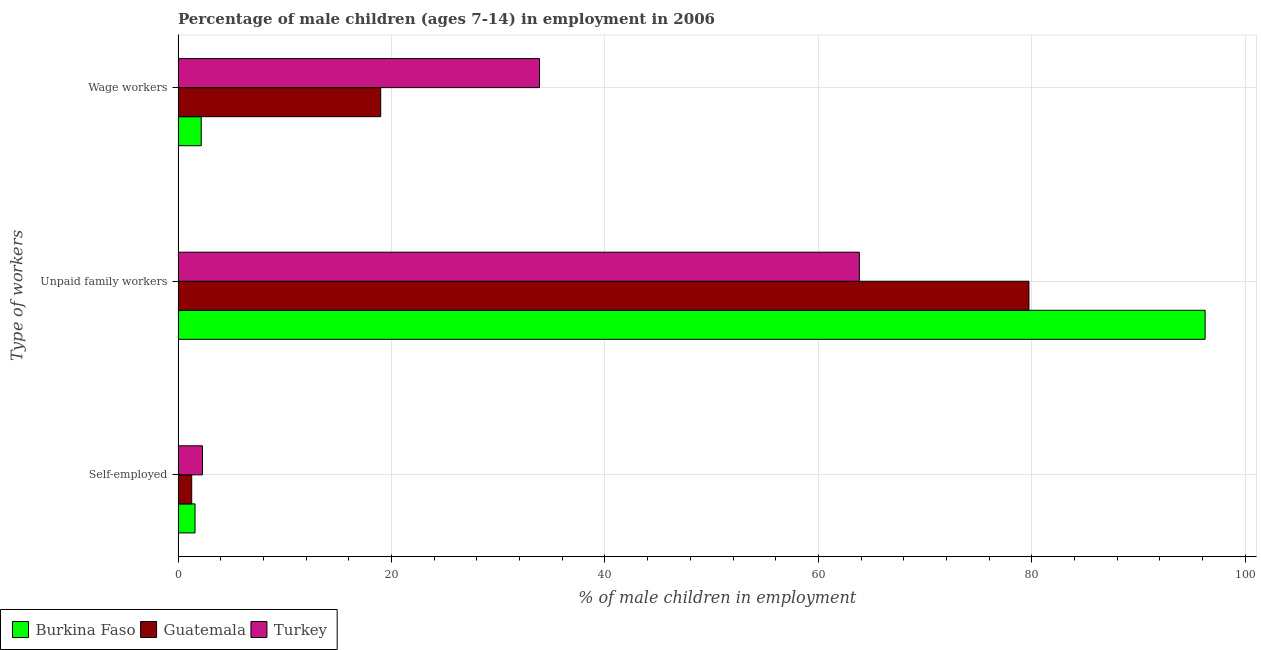How many groups of bars are there?
Offer a terse response. 3. Are the number of bars on each tick of the Y-axis equal?
Your response must be concise. Yes. How many bars are there on the 1st tick from the bottom?
Give a very brief answer. 3. What is the label of the 2nd group of bars from the top?
Your answer should be very brief. Unpaid family workers. What is the percentage of children employed as wage workers in Turkey?
Provide a succinct answer. 33.87. Across all countries, what is the maximum percentage of children employed as unpaid family workers?
Provide a succinct answer. 96.24. Across all countries, what is the minimum percentage of children employed as wage workers?
Make the answer very short. 2.17. In which country was the percentage of children employed as unpaid family workers maximum?
Offer a very short reply. Burkina Faso. What is the total percentage of children employed as unpaid family workers in the graph?
Provide a short and direct response. 239.81. What is the difference between the percentage of children employed as wage workers in Burkina Faso and that in Guatemala?
Provide a succinct answer. -16.82. What is the difference between the percentage of children employed as wage workers in Guatemala and the percentage of self employed children in Burkina Faso?
Your response must be concise. 17.4. What is the average percentage of self employed children per country?
Offer a terse response. 1.72. What is the difference between the percentage of self employed children and percentage of children employed as unpaid family workers in Guatemala?
Offer a very short reply. -78.45. What is the ratio of the percentage of children employed as wage workers in Guatemala to that in Turkey?
Your response must be concise. 0.56. Is the difference between the percentage of children employed as wage workers in Turkey and Guatemala greater than the difference between the percentage of self employed children in Turkey and Guatemala?
Provide a succinct answer. Yes. What is the difference between the highest and the second highest percentage of children employed as wage workers?
Your response must be concise. 14.88. In how many countries, is the percentage of self employed children greater than the average percentage of self employed children taken over all countries?
Provide a succinct answer. 1. Is the sum of the percentage of children employed as unpaid family workers in Burkina Faso and Turkey greater than the maximum percentage of children employed as wage workers across all countries?
Your response must be concise. Yes. What does the 2nd bar from the top in Wage workers represents?
Make the answer very short. Guatemala. What does the 2nd bar from the bottom in Self-employed represents?
Make the answer very short. Guatemala. How many bars are there?
Give a very brief answer. 9. Are all the bars in the graph horizontal?
Your answer should be compact. Yes. What is the difference between two consecutive major ticks on the X-axis?
Your answer should be compact. 20. Are the values on the major ticks of X-axis written in scientific E-notation?
Your response must be concise. No. Does the graph contain any zero values?
Offer a very short reply. No. Does the graph contain grids?
Your response must be concise. Yes. How many legend labels are there?
Offer a very short reply. 3. How are the legend labels stacked?
Keep it short and to the point. Horizontal. What is the title of the graph?
Ensure brevity in your answer.  Percentage of male children (ages 7-14) in employment in 2006. What is the label or title of the X-axis?
Make the answer very short. % of male children in employment. What is the label or title of the Y-axis?
Ensure brevity in your answer.  Type of workers. What is the % of male children in employment of Burkina Faso in Self-employed?
Your response must be concise. 1.59. What is the % of male children in employment in Guatemala in Self-employed?
Make the answer very short. 1.28. What is the % of male children in employment in Turkey in Self-employed?
Offer a very short reply. 2.29. What is the % of male children in employment of Burkina Faso in Unpaid family workers?
Give a very brief answer. 96.24. What is the % of male children in employment of Guatemala in Unpaid family workers?
Ensure brevity in your answer.  79.73. What is the % of male children in employment in Turkey in Unpaid family workers?
Offer a terse response. 63.84. What is the % of male children in employment of Burkina Faso in Wage workers?
Make the answer very short. 2.17. What is the % of male children in employment in Guatemala in Wage workers?
Make the answer very short. 18.99. What is the % of male children in employment of Turkey in Wage workers?
Make the answer very short. 33.87. Across all Type of workers, what is the maximum % of male children in employment in Burkina Faso?
Your answer should be very brief. 96.24. Across all Type of workers, what is the maximum % of male children in employment of Guatemala?
Offer a very short reply. 79.73. Across all Type of workers, what is the maximum % of male children in employment in Turkey?
Provide a succinct answer. 63.84. Across all Type of workers, what is the minimum % of male children in employment in Burkina Faso?
Ensure brevity in your answer.  1.59. Across all Type of workers, what is the minimum % of male children in employment of Guatemala?
Offer a very short reply. 1.28. Across all Type of workers, what is the minimum % of male children in employment of Turkey?
Ensure brevity in your answer.  2.29. What is the total % of male children in employment in Guatemala in the graph?
Give a very brief answer. 100. What is the total % of male children in employment of Turkey in the graph?
Your answer should be very brief. 100. What is the difference between the % of male children in employment of Burkina Faso in Self-employed and that in Unpaid family workers?
Keep it short and to the point. -94.65. What is the difference between the % of male children in employment of Guatemala in Self-employed and that in Unpaid family workers?
Your response must be concise. -78.45. What is the difference between the % of male children in employment in Turkey in Self-employed and that in Unpaid family workers?
Your answer should be very brief. -61.55. What is the difference between the % of male children in employment of Burkina Faso in Self-employed and that in Wage workers?
Your answer should be very brief. -0.58. What is the difference between the % of male children in employment of Guatemala in Self-employed and that in Wage workers?
Give a very brief answer. -17.71. What is the difference between the % of male children in employment of Turkey in Self-employed and that in Wage workers?
Offer a terse response. -31.58. What is the difference between the % of male children in employment of Burkina Faso in Unpaid family workers and that in Wage workers?
Your answer should be very brief. 94.07. What is the difference between the % of male children in employment in Guatemala in Unpaid family workers and that in Wage workers?
Your answer should be compact. 60.74. What is the difference between the % of male children in employment of Turkey in Unpaid family workers and that in Wage workers?
Make the answer very short. 29.97. What is the difference between the % of male children in employment in Burkina Faso in Self-employed and the % of male children in employment in Guatemala in Unpaid family workers?
Make the answer very short. -78.14. What is the difference between the % of male children in employment of Burkina Faso in Self-employed and the % of male children in employment of Turkey in Unpaid family workers?
Your answer should be compact. -62.25. What is the difference between the % of male children in employment in Guatemala in Self-employed and the % of male children in employment in Turkey in Unpaid family workers?
Provide a short and direct response. -62.56. What is the difference between the % of male children in employment in Burkina Faso in Self-employed and the % of male children in employment in Guatemala in Wage workers?
Provide a succinct answer. -17.4. What is the difference between the % of male children in employment of Burkina Faso in Self-employed and the % of male children in employment of Turkey in Wage workers?
Ensure brevity in your answer.  -32.28. What is the difference between the % of male children in employment in Guatemala in Self-employed and the % of male children in employment in Turkey in Wage workers?
Make the answer very short. -32.59. What is the difference between the % of male children in employment of Burkina Faso in Unpaid family workers and the % of male children in employment of Guatemala in Wage workers?
Ensure brevity in your answer.  77.25. What is the difference between the % of male children in employment in Burkina Faso in Unpaid family workers and the % of male children in employment in Turkey in Wage workers?
Offer a very short reply. 62.37. What is the difference between the % of male children in employment in Guatemala in Unpaid family workers and the % of male children in employment in Turkey in Wage workers?
Your answer should be very brief. 45.86. What is the average % of male children in employment of Burkina Faso per Type of workers?
Ensure brevity in your answer.  33.33. What is the average % of male children in employment in Guatemala per Type of workers?
Your response must be concise. 33.33. What is the average % of male children in employment in Turkey per Type of workers?
Offer a terse response. 33.33. What is the difference between the % of male children in employment in Burkina Faso and % of male children in employment in Guatemala in Self-employed?
Provide a succinct answer. 0.31. What is the difference between the % of male children in employment in Guatemala and % of male children in employment in Turkey in Self-employed?
Provide a succinct answer. -1.01. What is the difference between the % of male children in employment of Burkina Faso and % of male children in employment of Guatemala in Unpaid family workers?
Your answer should be very brief. 16.51. What is the difference between the % of male children in employment of Burkina Faso and % of male children in employment of Turkey in Unpaid family workers?
Provide a short and direct response. 32.4. What is the difference between the % of male children in employment in Guatemala and % of male children in employment in Turkey in Unpaid family workers?
Give a very brief answer. 15.89. What is the difference between the % of male children in employment in Burkina Faso and % of male children in employment in Guatemala in Wage workers?
Make the answer very short. -16.82. What is the difference between the % of male children in employment of Burkina Faso and % of male children in employment of Turkey in Wage workers?
Provide a succinct answer. -31.7. What is the difference between the % of male children in employment in Guatemala and % of male children in employment in Turkey in Wage workers?
Your response must be concise. -14.88. What is the ratio of the % of male children in employment in Burkina Faso in Self-employed to that in Unpaid family workers?
Keep it short and to the point. 0.02. What is the ratio of the % of male children in employment of Guatemala in Self-employed to that in Unpaid family workers?
Keep it short and to the point. 0.02. What is the ratio of the % of male children in employment of Turkey in Self-employed to that in Unpaid family workers?
Make the answer very short. 0.04. What is the ratio of the % of male children in employment of Burkina Faso in Self-employed to that in Wage workers?
Ensure brevity in your answer.  0.73. What is the ratio of the % of male children in employment in Guatemala in Self-employed to that in Wage workers?
Ensure brevity in your answer.  0.07. What is the ratio of the % of male children in employment in Turkey in Self-employed to that in Wage workers?
Your response must be concise. 0.07. What is the ratio of the % of male children in employment of Burkina Faso in Unpaid family workers to that in Wage workers?
Make the answer very short. 44.35. What is the ratio of the % of male children in employment in Guatemala in Unpaid family workers to that in Wage workers?
Provide a short and direct response. 4.2. What is the ratio of the % of male children in employment in Turkey in Unpaid family workers to that in Wage workers?
Provide a succinct answer. 1.88. What is the difference between the highest and the second highest % of male children in employment in Burkina Faso?
Keep it short and to the point. 94.07. What is the difference between the highest and the second highest % of male children in employment in Guatemala?
Provide a short and direct response. 60.74. What is the difference between the highest and the second highest % of male children in employment of Turkey?
Offer a very short reply. 29.97. What is the difference between the highest and the lowest % of male children in employment in Burkina Faso?
Your answer should be very brief. 94.65. What is the difference between the highest and the lowest % of male children in employment in Guatemala?
Make the answer very short. 78.45. What is the difference between the highest and the lowest % of male children in employment in Turkey?
Make the answer very short. 61.55. 